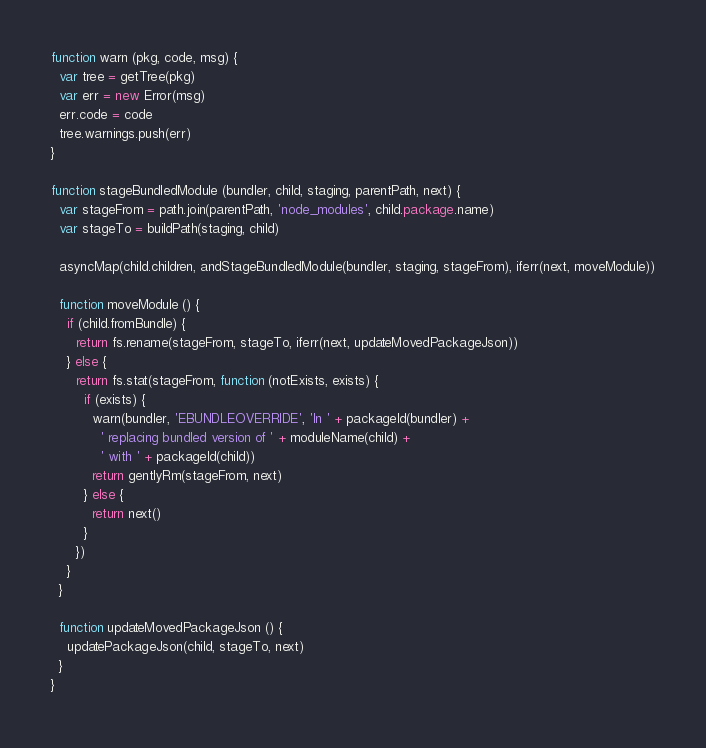Convert code to text. <code><loc_0><loc_0><loc_500><loc_500><_JavaScript_>
function warn (pkg, code, msg) {
  var tree = getTree(pkg)
  var err = new Error(msg)
  err.code = code
  tree.warnings.push(err)
}

function stageBundledModule (bundler, child, staging, parentPath, next) {
  var stageFrom = path.join(parentPath, 'node_modules', child.package.name)
  var stageTo = buildPath(staging, child)

  asyncMap(child.children, andStageBundledModule(bundler, staging, stageFrom), iferr(next, moveModule))

  function moveModule () {
    if (child.fromBundle) {
      return fs.rename(stageFrom, stageTo, iferr(next, updateMovedPackageJson))
    } else {
      return fs.stat(stageFrom, function (notExists, exists) {
        if (exists) {
          warn(bundler, 'EBUNDLEOVERRIDE', 'In ' + packageId(bundler) +
            ' replacing bundled version of ' + moduleName(child) +
            ' with ' + packageId(child))
          return gentlyRm(stageFrom, next)
        } else {
          return next()
        }
      })
    }
  }

  function updateMovedPackageJson () {
    updatePackageJson(child, stageTo, next)
  }
}
</code> 